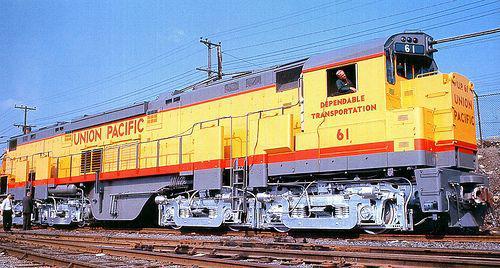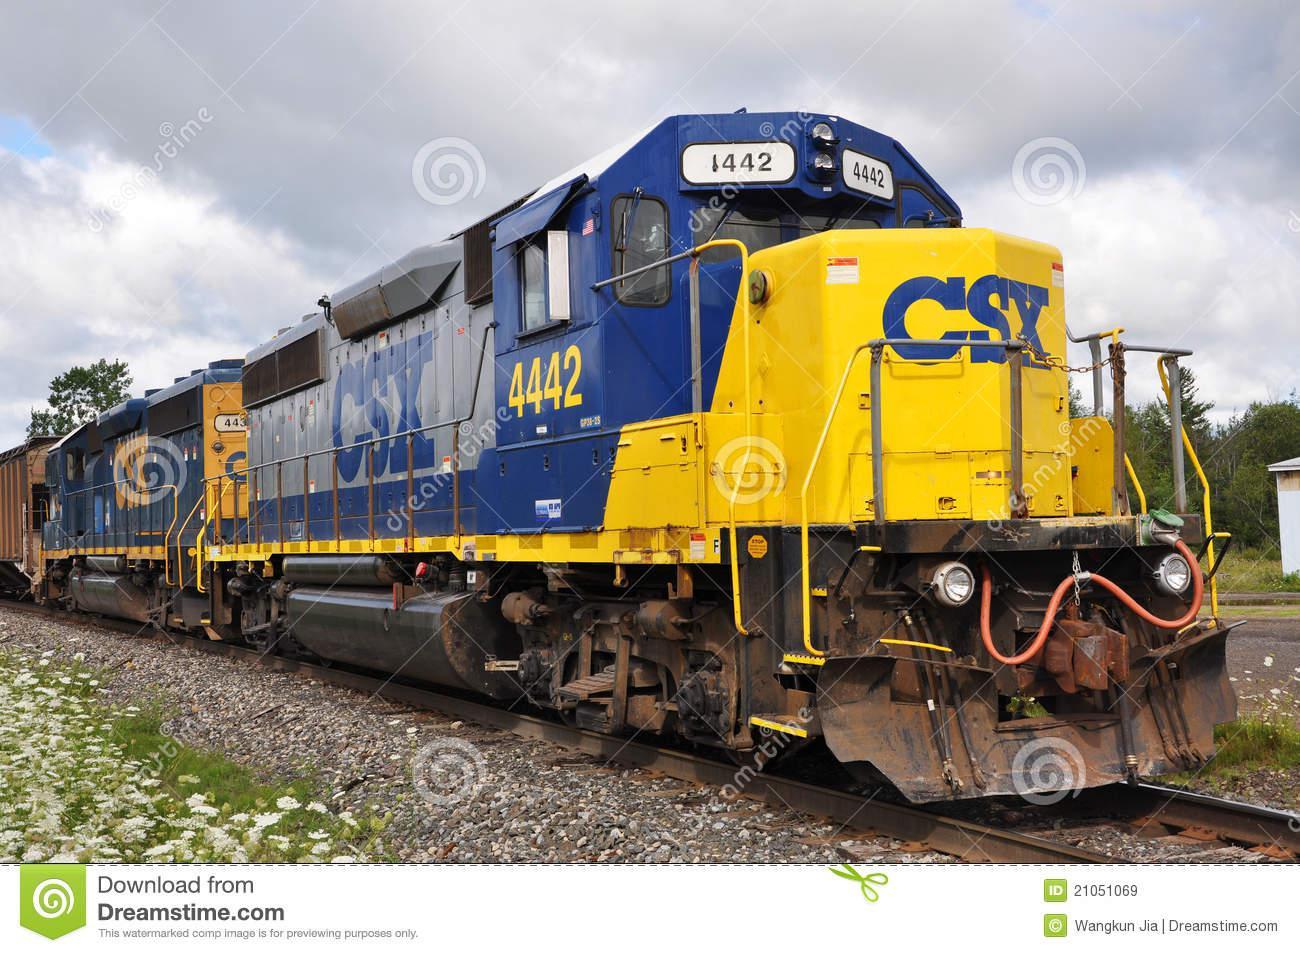The first image is the image on the left, the second image is the image on the right. Evaluate the accuracy of this statement regarding the images: "The train in the right image is facing left.". Is it true? Answer yes or no. No. The first image is the image on the left, the second image is the image on the right. For the images displayed, is the sentence "In one image there is a yellow and orange train sitting on rails in the center of the image." factually correct? Answer yes or no. Yes. 